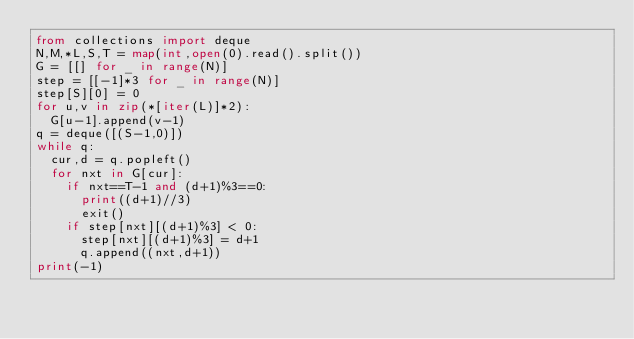Convert code to text. <code><loc_0><loc_0><loc_500><loc_500><_Python_>from collections import deque
N,M,*L,S,T = map(int,open(0).read().split())
G = [[] for _ in range(N)]
step = [[-1]*3 for _ in range(N)]
step[S][0] = 0
for u,v in zip(*[iter(L)]*2):
	G[u-1].append(v-1)
q = deque([(S-1,0)])
while q:
	cur,d = q.popleft()
	for nxt in G[cur]:
		if nxt==T-1 and (d+1)%3==0:
			print((d+1)//3)
			exit()
		if step[nxt][(d+1)%3] < 0:
			step[nxt][(d+1)%3] = d+1
			q.append((nxt,d+1))
print(-1)</code> 